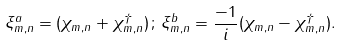Convert formula to latex. <formula><loc_0><loc_0><loc_500><loc_500>\xi ^ { a } _ { m , n } = ( \chi _ { m , n } + \chi ^ { \dagger } _ { m , n } ) \, ; \, \xi ^ { b } _ { m , n } = \frac { - 1 } { i } ( \chi _ { m , n } - \chi ^ { \dagger } _ { m , n } ) .</formula> 